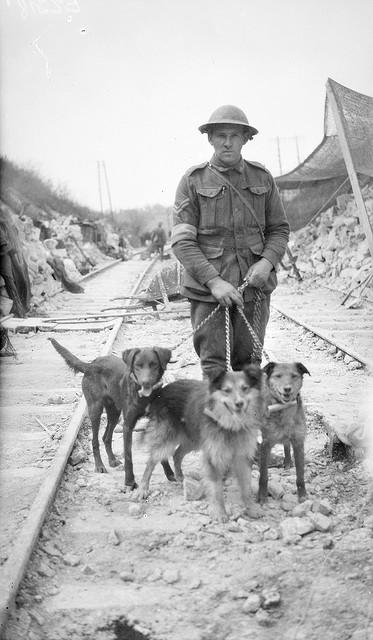What is on the man's head?
Keep it brief. Helmet. Is this a modern photo?
Short answer required. No. How many dogs are in the photo?
Concise answer only. 3. 